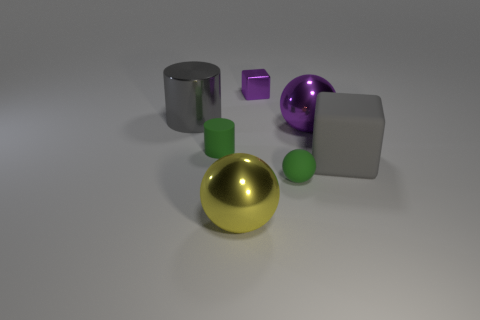What number of objects are either rubber things or small green cylinders?
Offer a very short reply. 3. The metal cylinder has what color?
Give a very brief answer. Gray. How many other objects are there of the same color as the tiny cylinder?
Offer a very short reply. 1. Are there any green cylinders right of the purple ball?
Your response must be concise. No. There is a big ball that is left of the purple metallic object that is on the right side of the green thing right of the big yellow sphere; what color is it?
Make the answer very short. Yellow. What number of large things are to the right of the gray cylinder and to the left of the purple block?
Make the answer very short. 1. How many cylinders are either small green objects or small gray metal objects?
Make the answer very short. 1. Are there any large purple objects?
Your answer should be compact. Yes. What number of other things are there of the same material as the small block
Offer a terse response. 3. What material is the purple thing that is the same size as the green rubber cylinder?
Offer a terse response. Metal. 